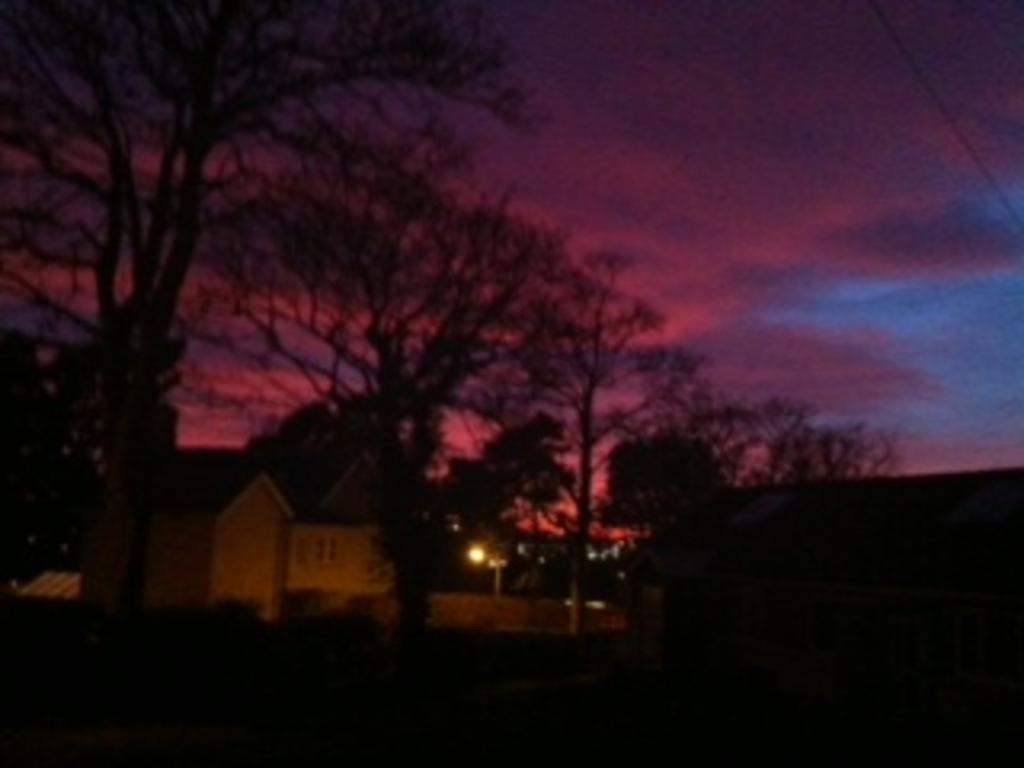What type of structures can be seen in the image? There are houses in the image. What other natural elements are present in the image? There are trees in the image. Can you describe the source of light in the image? There is a light in the image. What can be seen in the background of the image? The sky is visible in the background of the image. How many donkeys are grazing in the field in the image? There are no donkeys present in the image; it only features houses, trees, a light, and the sky. 